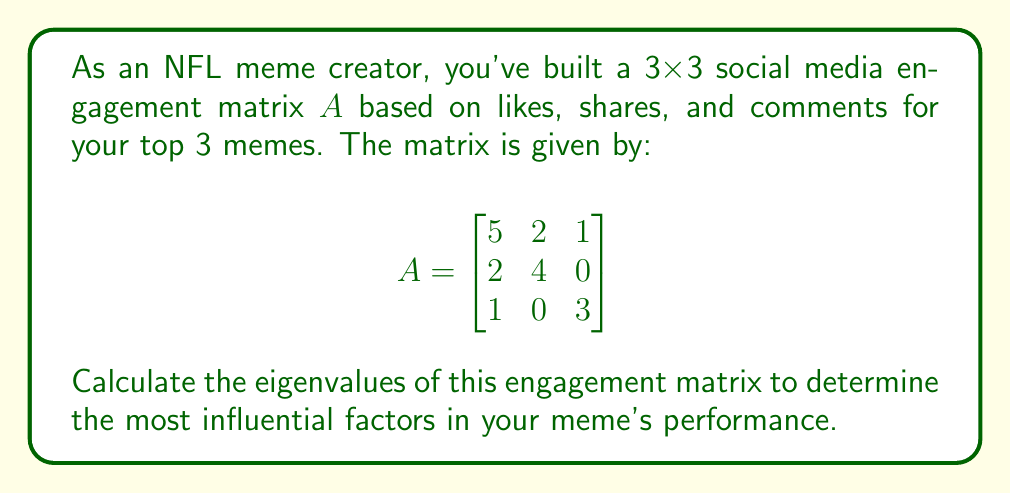Could you help me with this problem? To find the eigenvalues of matrix $A$, we need to solve the characteristic equation:

$\det(A - \lambda I) = 0$

where $\lambda$ represents the eigenvalues and $I$ is the 3x3 identity matrix.

Step 1: Set up the characteristic equation:
$$\det\begin{bmatrix}
5-\lambda & 2 & 1 \\
2 & 4-\lambda & 0 \\
1 & 0 & 3-\lambda
\end{bmatrix} = 0$$

Step 2: Expand the determinant:
$$(5-\lambda)[(4-\lambda)(3-\lambda) - 0] - 2[2(3-\lambda) - 0] + 1[2 \cdot 0 - (4-\lambda)] = 0$$

Step 3: Simplify:
$$(5-\lambda)(12-7\lambda+\lambda^2) - 2(6-2\lambda) + (4-\lambda) = 0$$
$$60-35\lambda+5\lambda^2-12\lambda+7\lambda^2-\lambda^3 - 12+4\lambda + 4-\lambda = 0$$

Step 4: Combine like terms:
$$-\lambda^3 + 12\lambda^2 - 44\lambda + 52 = 0$$

Step 5: Factor the cubic equation:
$$-(\lambda - 2)(\lambda^2 - 10\lambda + 26) = 0$$
$$-(\lambda - 2)(\lambda - 5)(\lambda - 5) = 0$$

Step 6: Solve for $\lambda$:
$\lambda = 2$ or $\lambda = 5$ (with multiplicity 2)
Answer: $\lambda_1 = 2$, $\lambda_2 = \lambda_3 = 5$ 